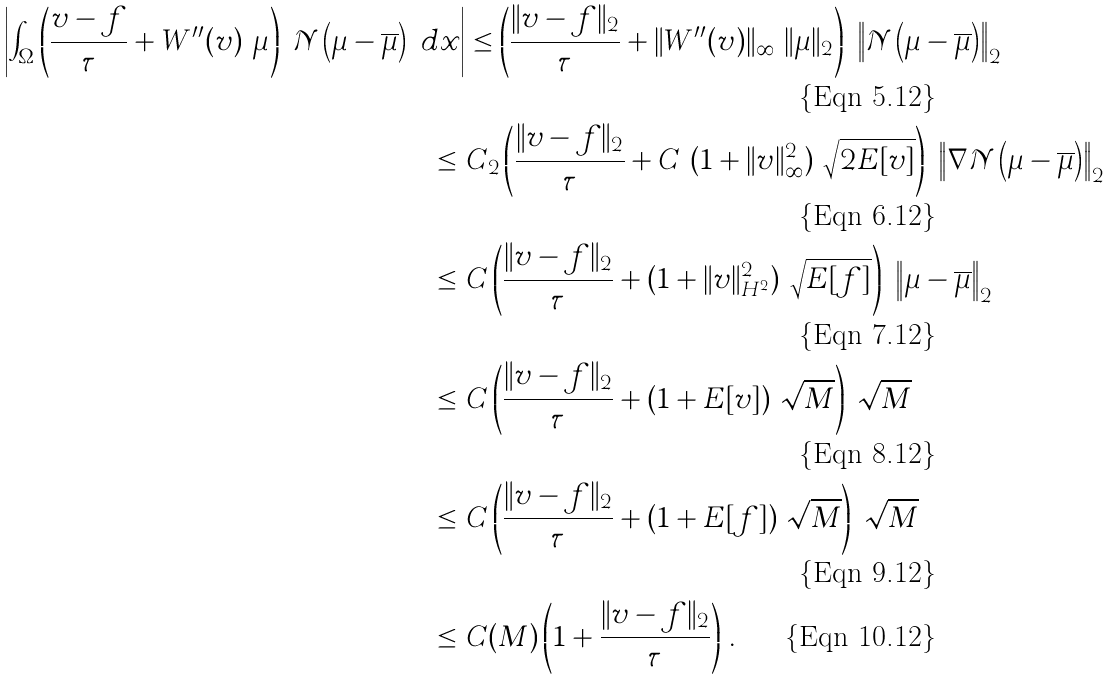Convert formula to latex. <formula><loc_0><loc_0><loc_500><loc_500>\left | \int _ { \Omega } \left ( \frac { v - f } { \tau } + W ^ { \prime \prime } ( v ) \ \mu \right ) \ \mathcal { N } \left ( \mu - \overline { \mu } \right ) \ d x \right | & \leq \left ( \frac { \| v - f \| _ { 2 } } { \tau } + \| W ^ { \prime \prime } ( v ) \| _ { \infty } \ \| \mu \| _ { 2 } \right ) \ \left \| \mathcal { N } \left ( \mu - \overline { \mu } \right ) \right \| _ { 2 } \\ \leq \ & C _ { 2 } \left ( \frac { \| v - f \| _ { 2 } } { \tau } + C \ ( 1 + \| v \| _ { \infty } ^ { 2 } ) \ \sqrt { 2 E [ v ] } \right ) \ \left \| \nabla \mathcal { N } \left ( \mu - \overline { \mu } \right ) \right \| _ { 2 } \\ \leq \ & C \left ( \frac { \| v - f \| _ { 2 } } { \tau } + ( 1 + \| v \| _ { H ^ { 2 } } ^ { 2 } ) \ \sqrt { E [ f ] } \right ) \ \left \| \mu - \overline { \mu } \right \| _ { 2 } \\ \leq \ & C \left ( \frac { \| v - f \| _ { 2 } } { \tau } + ( 1 + E [ v ] ) \ \sqrt { M } \right ) \ \sqrt { M } \\ \leq \ & C \left ( \frac { \| v - f \| _ { 2 } } { \tau } + ( 1 + E [ f ] ) \ \sqrt { M } \right ) \ \sqrt { M } \\ \leq \ & C ( M ) \left ( 1 + \frac { \| v - f \| _ { 2 } } { \tau } \right ) \, .</formula> 